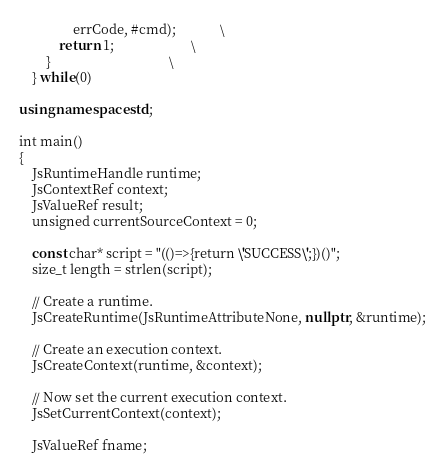Convert code to text. <code><loc_0><loc_0><loc_500><loc_500><_C++_>                errCode, #cmd);             \
            return 1;                       \
        }                                   \
    } while(0)

using namespace std;

int main()
{
    JsRuntimeHandle runtime;
    JsContextRef context;
    JsValueRef result;
    unsigned currentSourceContext = 0;

    const char* script = "(()=>{return \'SUCCESS\';})()";
    size_t length = strlen(script);

    // Create a runtime.
    JsCreateRuntime(JsRuntimeAttributeNone, nullptr, &runtime);

    // Create an execution context.
    JsCreateContext(runtime, &context);

    // Now set the current execution context.
    JsSetCurrentContext(context);

    JsValueRef fname;</code> 